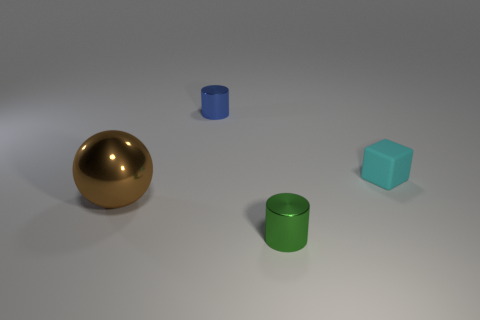What shape is the thing that is to the right of the tiny shiny cylinder in front of the shiny object behind the sphere? cube 